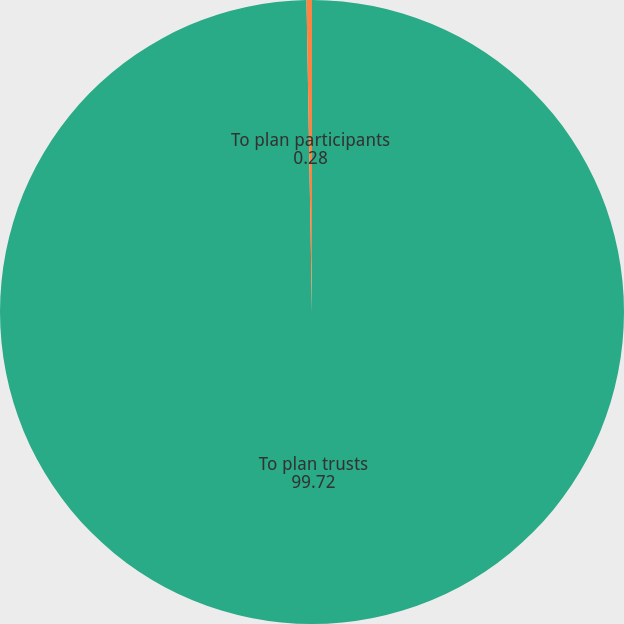Convert chart. <chart><loc_0><loc_0><loc_500><loc_500><pie_chart><fcel>To plan trusts<fcel>To plan participants<nl><fcel>99.72%<fcel>0.28%<nl></chart> 